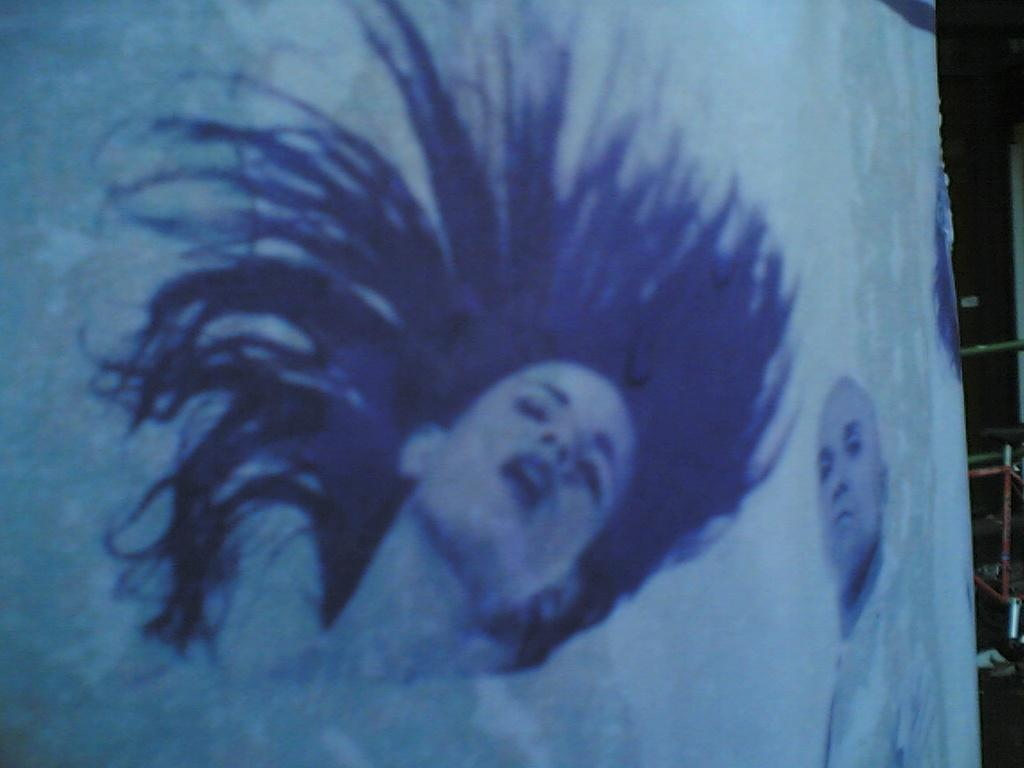What is depicted on the banner in the image? There is a picture of a woman and a man on a banner in the image. What can be seen on the right side of the image? There are metal rods onds on the right side of the image. How many clovers are present in the image? There are no clovers present in the image. What type of furniture can be seen in the image? There is no furniture present in the image. 